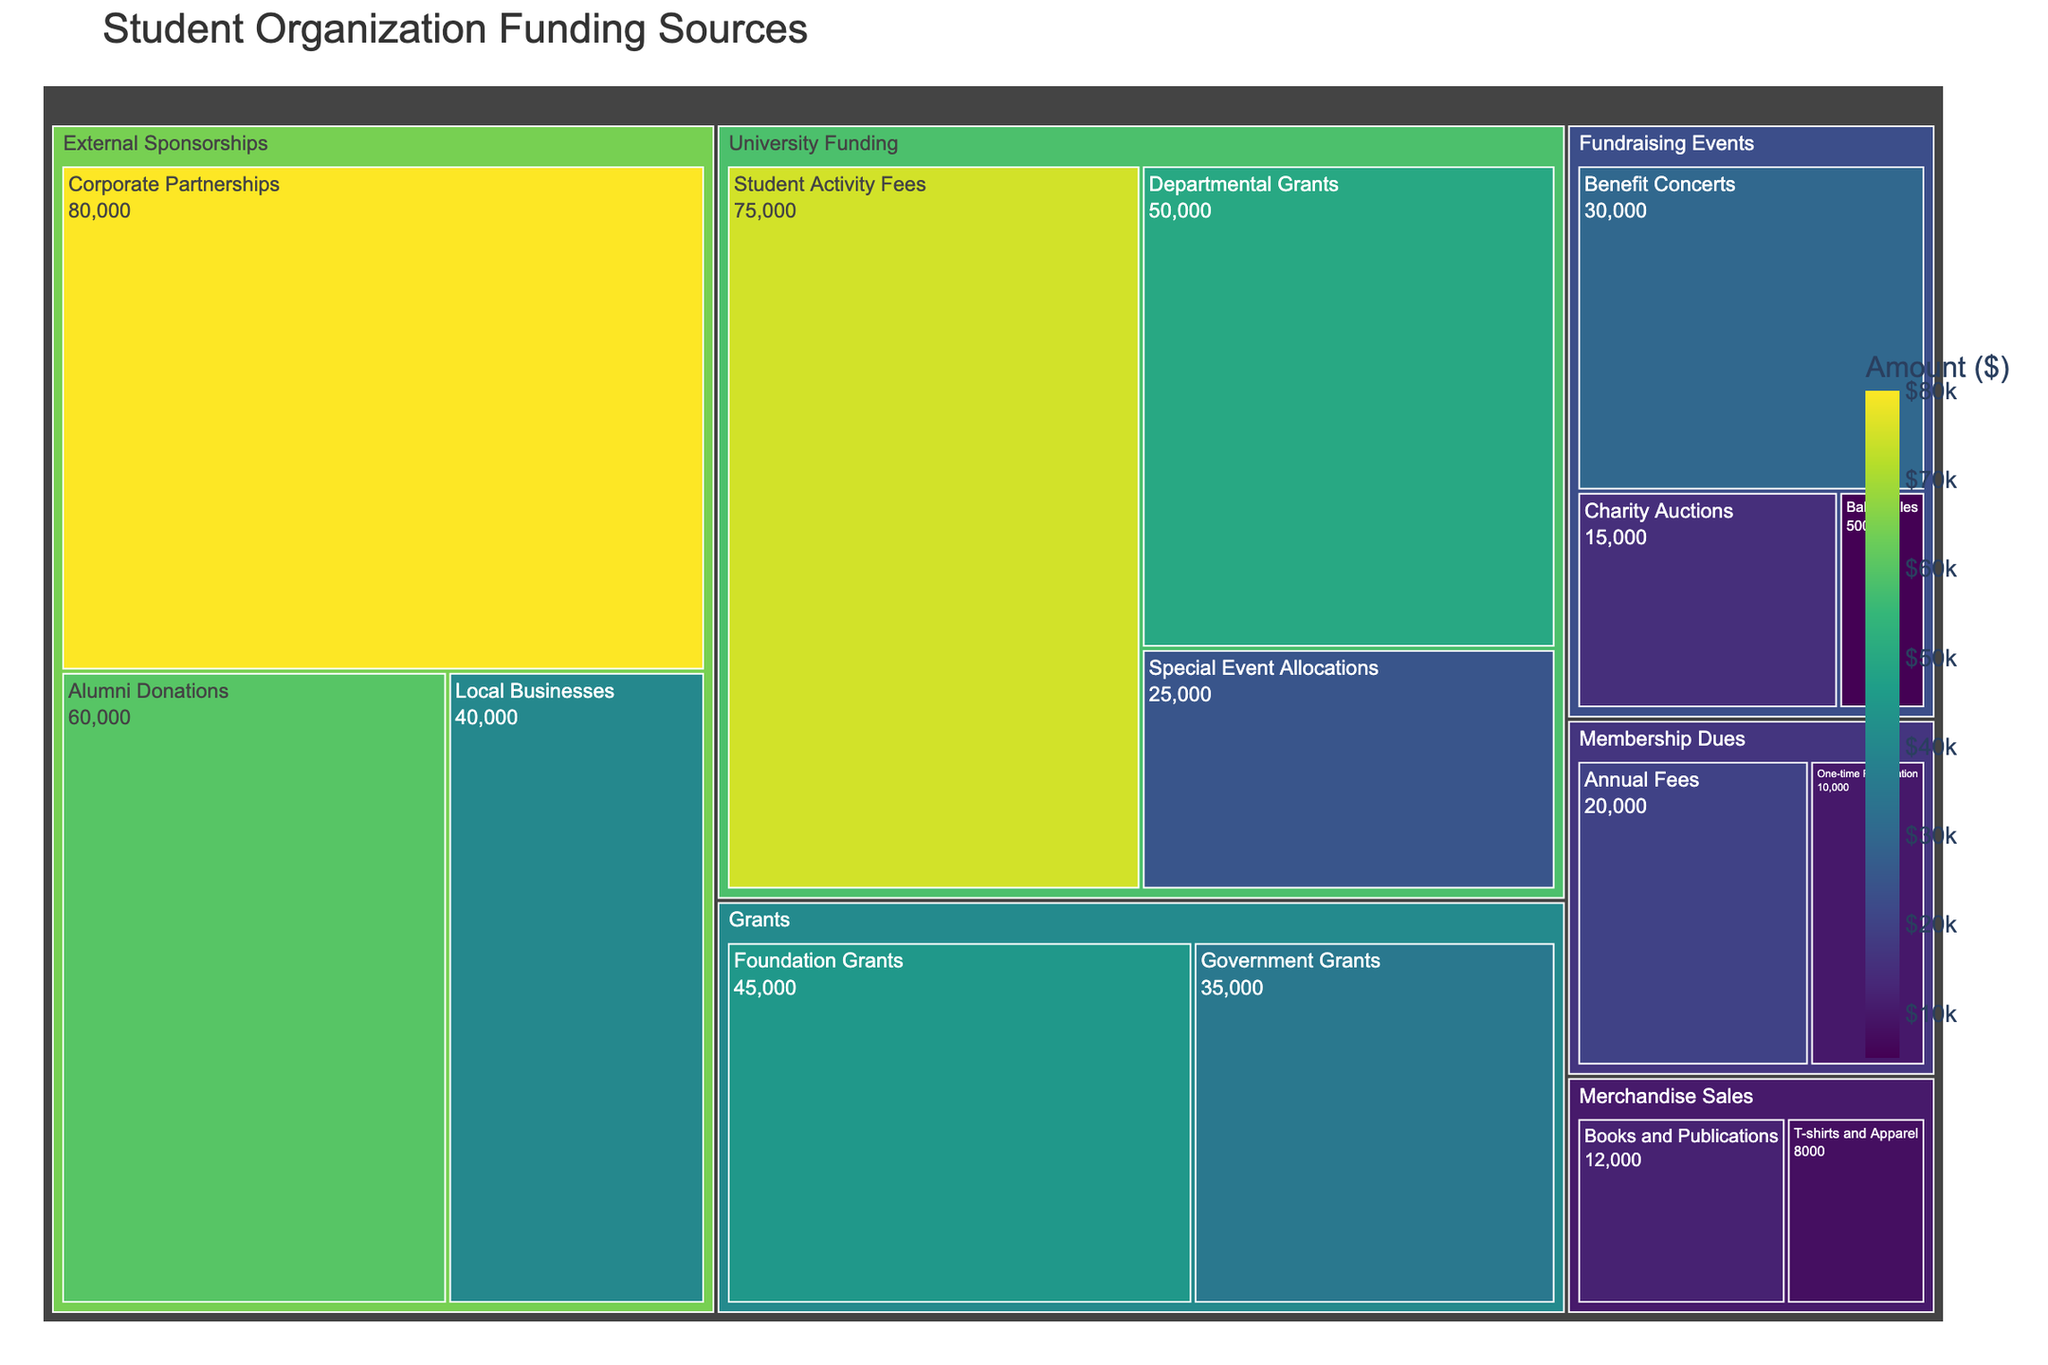What is the title of the treemap? The title of a treemap is typically located at the top of the plot and summarized in a larger font size compared to other elements. In this case, the title can be observed as "Student Organization Funding Sources" from the plot's visual information.
Answer: Student Organization Funding Sources Which subcategory has the highest amount of funding? By looking at the various segments in the treemap, the size and the color coding (where higher amounts likely have darker colors according to 'Viridis' scale), the corporate partnerships subcategory with an amount of $80,000 is the largest and darkest indicating it has the highest funding.
Answer: Corporate Partnerships What is the total amount of University Funding? University Funding is a main category consisting of three subcategories. Add their amounts: Student Activity Fees ($75,000) + Departmental Grants ($50,000) + Special Event Allocations ($25,000) = $150,000.
Answer: $150,000 Compare the total funding from Membership Dues to that from Merchandise Sales. Which is higher, and by how much? Sum up the subcategory amounts for both Membership Dues (Annual Fees $20,000 + One-time Registration $10,000 = $30,000) and Merchandise Sales (T-shirts and Apparel $8,000 + Books and Publications $12,000 = $20,000). Then, subtract the two totals: $30,000 - $20,000 = $10,000. Membership Dues is higher by $10,000.
Answer: Membership Dues are higher by $10,000 What percentage of the total funding is provided by Government Grants? First, find the total funding by summing all amounts in the figure. Total = $75,000 + $50,000 + $25,000 + $40,000 + $60,000 + $80,000 + $5,000 + $15,000 + $30,000 + $20,000 + $10,000 + $45,000 + $35,000 + $8,000 + $12,000 = $510,000. Next, calculate the percentage for Government Grants: ($35,000 / $510,000) * 100 ≈ 6.86%.
Answer: Approximately 6.86% How does the amount from Alumni Donations compare to the total amount from Fundraising Events? Compare the amount from Alumni Donations ($60,000) directly to the total from all Fundraising Events: $5,000 + $15,000 + $30,000 = $50,000. Alumni Donations have more funding, with a difference of $60,000 - $50,000 = $10,000.
Answer: Alumni Donations have $10,000 more than Fundraising Events If the funding from Special Event Allocations were doubled, what would the new total amount of University Funding be? Doubling the amount from Special Event Allocations results in $25,000 * 2 = $50,000. Adjust the total University Funding accordingly: $75,000 (Student Activity Fees) + $50,000 (Departmental Grants) + $50,000 (new Special Event Allocations) = $175,000.
Answer: $175,000 What’s the combined amount of funding for the top two highest-funded subcategories? Identify the top two highest-funded subcategories: Corporate Partnerships ($80,000) and Student Activity Fees ($75,000). Their combined funding amount is $80,000 + $75,000 = $155,000.
Answer: $155,000 